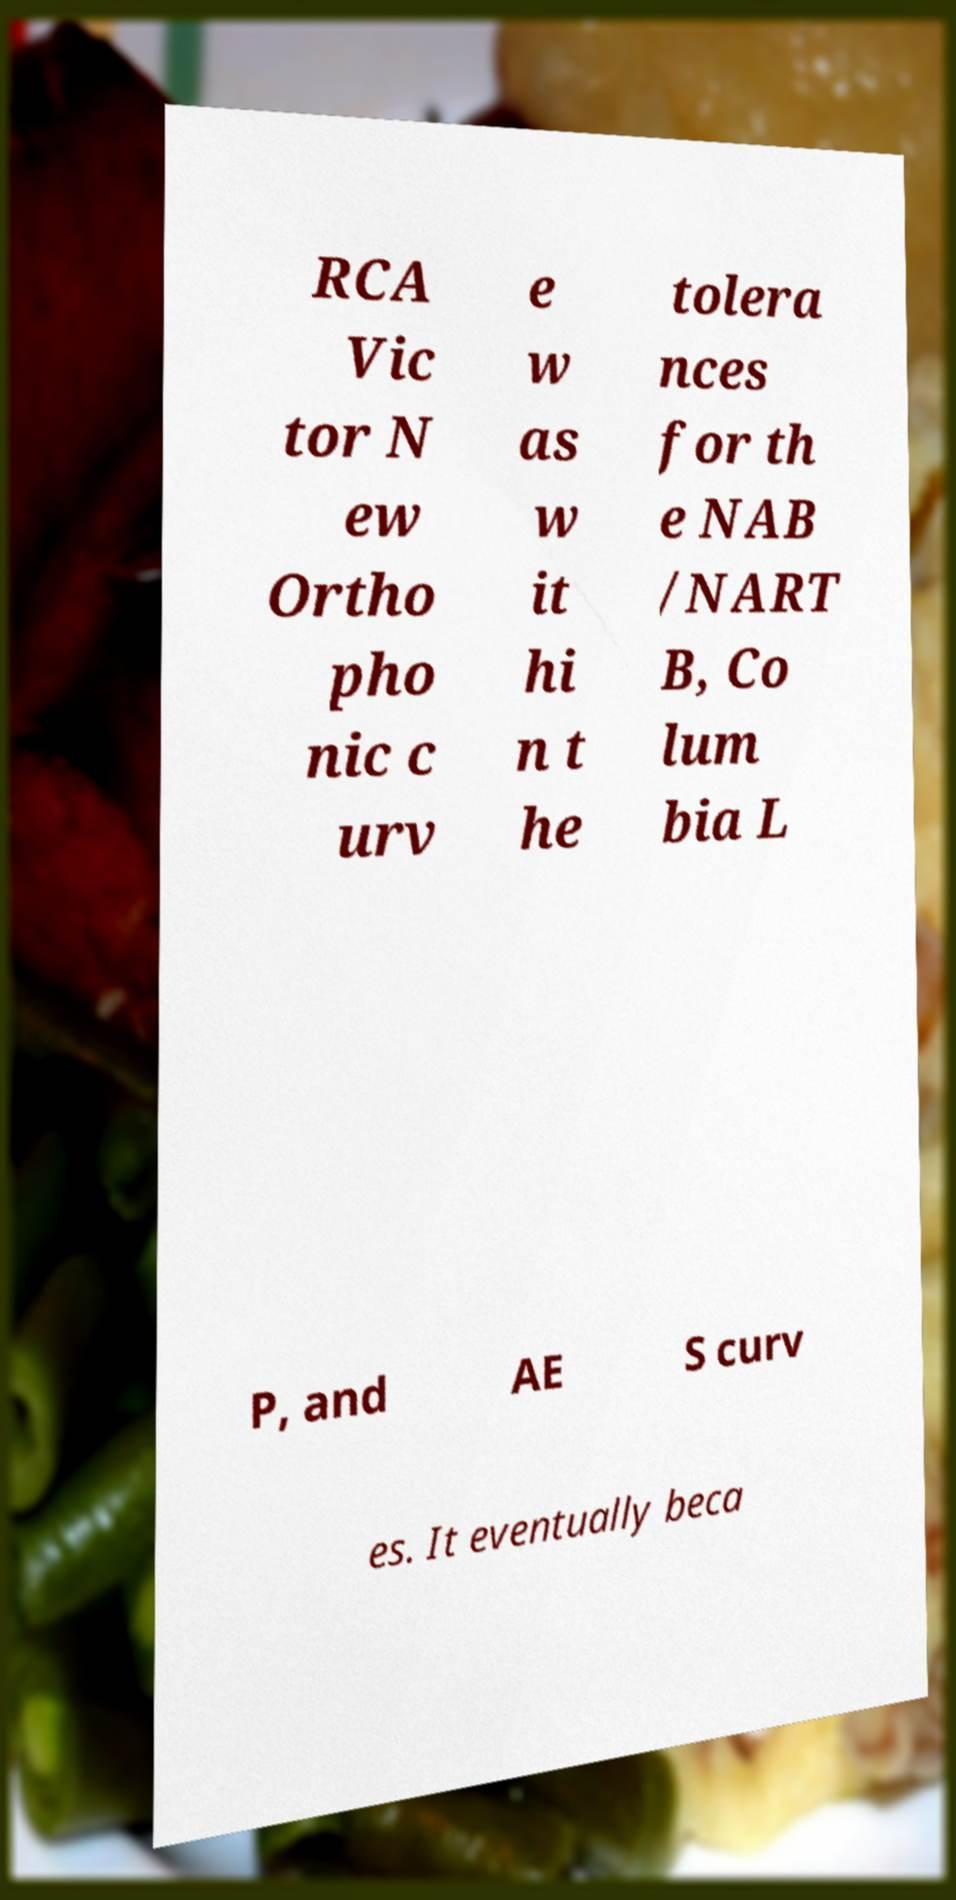There's text embedded in this image that I need extracted. Can you transcribe it verbatim? RCA Vic tor N ew Ortho pho nic c urv e w as w it hi n t he tolera nces for th e NAB /NART B, Co lum bia L P, and AE S curv es. It eventually beca 